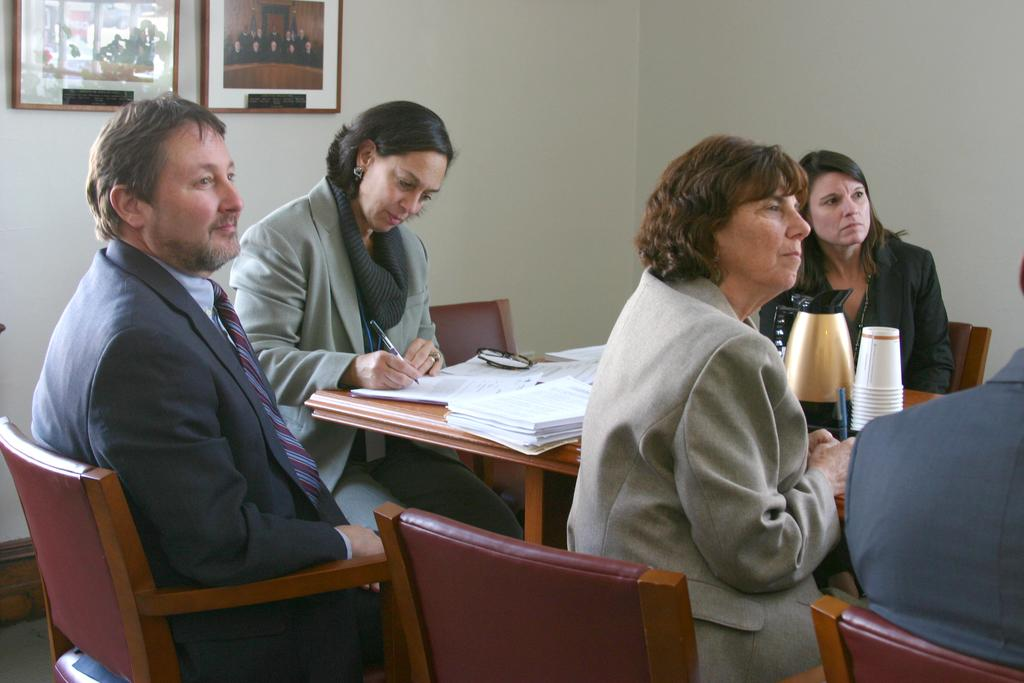What are the people in the image doing? There is a group of people sitting on chairs. What is the lady with the pen doing? One lady is writing with a pen on a book. What can be found on the table in the image? There is a flask and two photo frames on the table. How many horses are visible in the image? There are no horses present in the image. What is the value of the dime on the table in the image? There is no dime present in the image. 